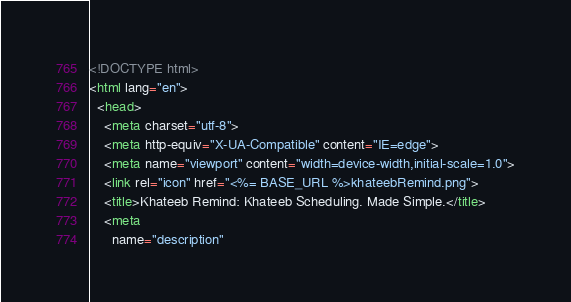<code> <loc_0><loc_0><loc_500><loc_500><_HTML_><!DOCTYPE html>
<html lang="en">
  <head>
    <meta charset="utf-8">
    <meta http-equiv="X-UA-Compatible" content="IE=edge">
    <meta name="viewport" content="width=device-width,initial-scale=1.0">
    <link rel="icon" href="<%= BASE_URL %>khateebRemind.png">
    <title>Khateeb Remind: Khateeb Scheduling. Made Simple.</title>
    <meta 
      name="description"</code> 